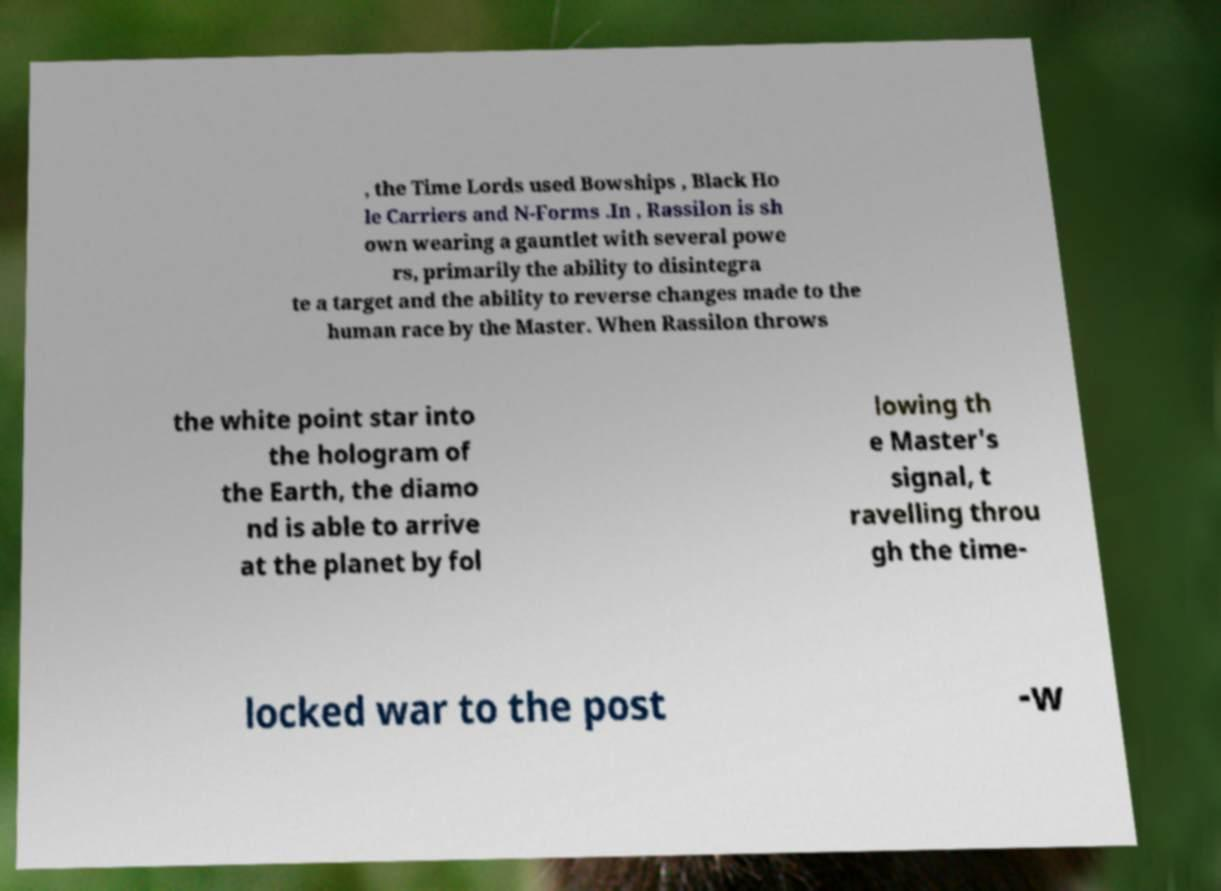Please read and relay the text visible in this image. What does it say? , the Time Lords used Bowships , Black Ho le Carriers and N-Forms .In , Rassilon is sh own wearing a gauntlet with several powe rs, primarily the ability to disintegra te a target and the ability to reverse changes made to the human race by the Master. When Rassilon throws the white point star into the hologram of the Earth, the diamo nd is able to arrive at the planet by fol lowing th e Master's signal, t ravelling throu gh the time- locked war to the post -w 